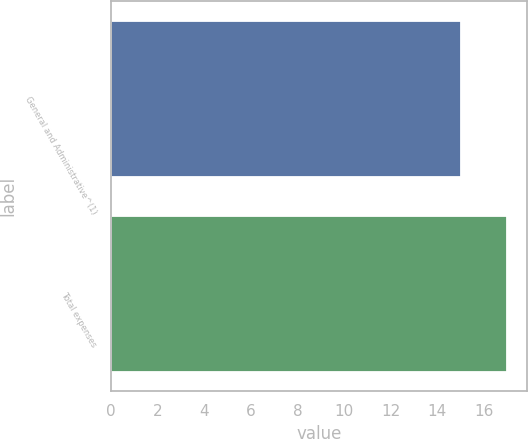<chart> <loc_0><loc_0><loc_500><loc_500><bar_chart><fcel>General and Administrative^(1)<fcel>Total expenses<nl><fcel>15<fcel>17<nl></chart> 